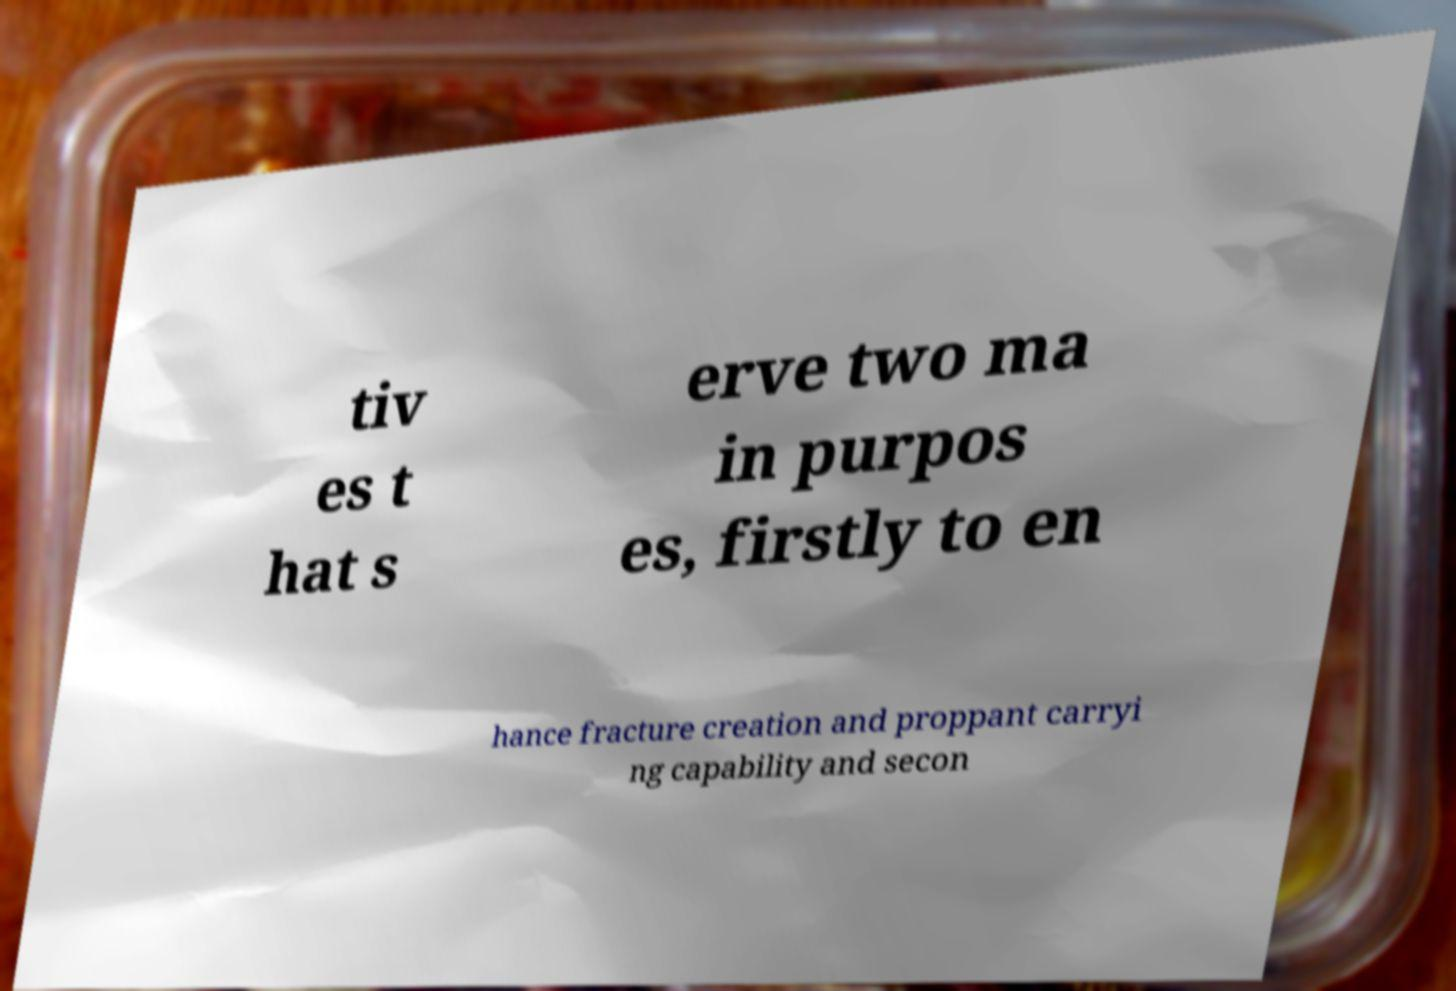Please identify and transcribe the text found in this image. tiv es t hat s erve two ma in purpos es, firstly to en hance fracture creation and proppant carryi ng capability and secon 